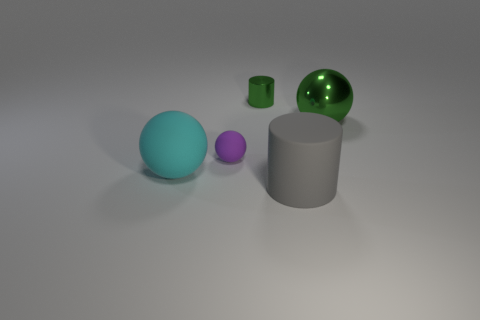Is there a large shiny thing that has the same color as the tiny cylinder?
Your response must be concise. Yes. There is a ball that is right of the small green metallic thing; is its color the same as the tiny cylinder?
Offer a terse response. Yes. How many other objects are there of the same size as the green ball?
Ensure brevity in your answer.  2. There is a small metal thing; is its color the same as the metal thing right of the big gray cylinder?
Provide a short and direct response. Yes. How many objects are either tiny yellow cylinders or small spheres?
Keep it short and to the point. 1. Is there any other thing of the same color as the small cylinder?
Your answer should be compact. Yes. Does the tiny cylinder have the same material as the big object to the left of the big cylinder?
Provide a succinct answer. No. What shape is the big rubber thing that is to the right of the large rubber sphere in front of the tiny green cylinder?
Your answer should be very brief. Cylinder. There is a object that is both behind the purple sphere and in front of the small metallic thing; what shape is it?
Make the answer very short. Sphere. How many things are either cyan matte things or rubber objects that are behind the cyan rubber ball?
Your response must be concise. 2. 